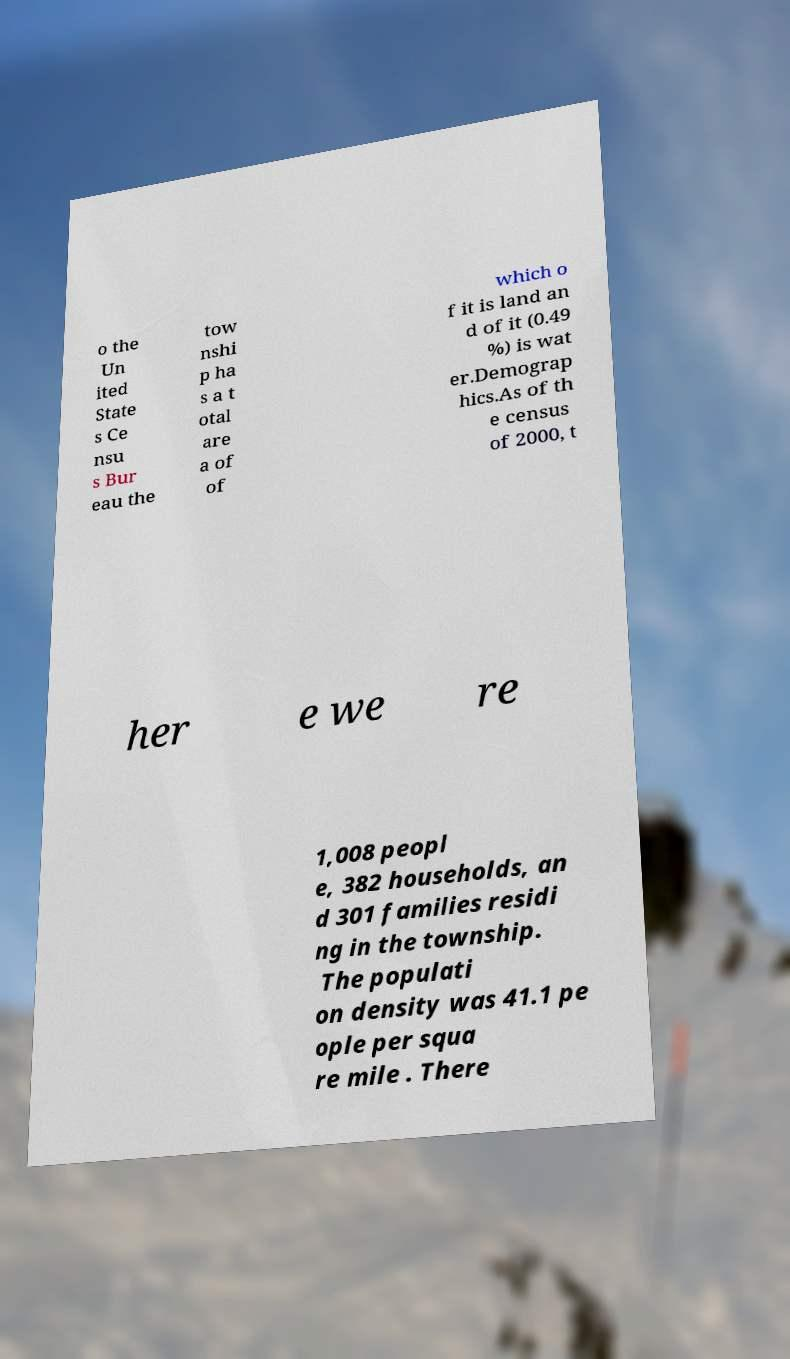Could you assist in decoding the text presented in this image and type it out clearly? o the Un ited State s Ce nsu s Bur eau the tow nshi p ha s a t otal are a of of which o f it is land an d of it (0.49 %) is wat er.Demograp hics.As of th e census of 2000, t her e we re 1,008 peopl e, 382 households, an d 301 families residi ng in the township. The populati on density was 41.1 pe ople per squa re mile . There 